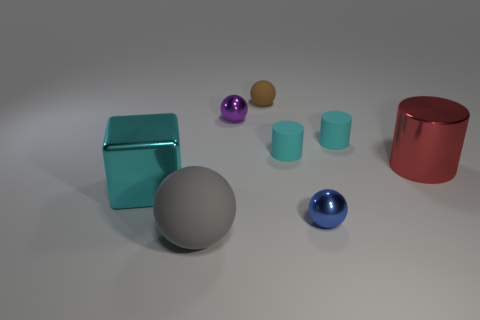The shiny sphere that is to the left of the matte sphere that is right of the large rubber thing is what color?
Make the answer very short. Purple. There is a gray thing that is the same shape as the brown object; what size is it?
Your response must be concise. Large. What number of tiny purple balls are the same material as the tiny blue thing?
Make the answer very short. 1. There is a large metallic object that is on the left side of the tiny purple metallic thing; what number of rubber objects are in front of it?
Provide a succinct answer. 1. There is a purple sphere; are there any large cyan metal blocks in front of it?
Your response must be concise. Yes. Is the shape of the small metal object that is right of the tiny brown sphere the same as  the purple shiny thing?
Your answer should be compact. Yes. How many matte objects have the same color as the shiny cube?
Give a very brief answer. 2. There is a big red metal object that is right of the small shiny thing that is behind the shiny cylinder; what is its shape?
Offer a very short reply. Cylinder. Are there any small blue objects that have the same shape as the brown matte object?
Your response must be concise. Yes. There is a big sphere; does it have the same color as the metal ball that is in front of the purple object?
Offer a terse response. No. 